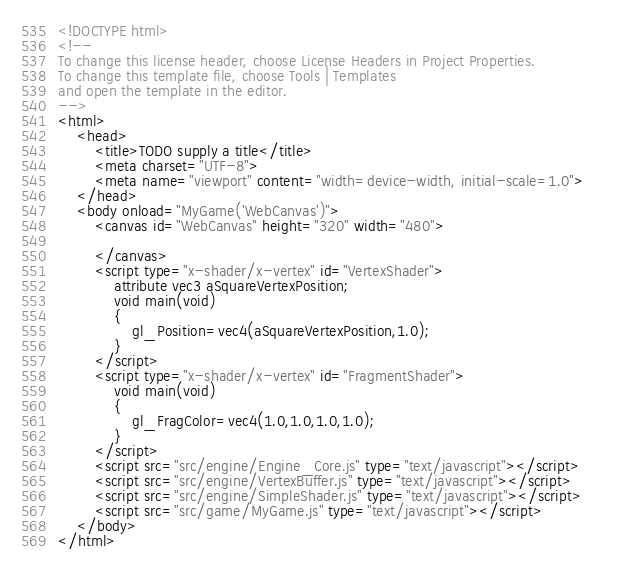Convert code to text. <code><loc_0><loc_0><loc_500><loc_500><_HTML_><!DOCTYPE html>
<!--
To change this license header, choose License Headers in Project Properties.
To change this template file, choose Tools | Templates
and open the template in the editor.
-->
<html>
    <head>
        <title>TODO supply a title</title>
        <meta charset="UTF-8">
        <meta name="viewport" content="width=device-width, initial-scale=1.0">
    </head>
    <body onload="MyGame('WebCanvas')">
        <canvas id="WebCanvas" height="320" width="480">
            
        </canvas>
        <script type="x-shader/x-vertex" id="VertexShader">
            attribute vec3 aSquareVertexPosition;
            void main(void)
            {
                gl_Position=vec4(aSquareVertexPosition,1.0);
            }
        </script>
        <script type="x-shader/x-vertex" id="FragmentShader">
            void main(void)
            {
                gl_FragColor=vec4(1.0,1.0,1.0,1.0);
            }
        </script>
        <script src="src/engine/Engine_Core.js" type="text/javascript"></script>
        <script src="src/engine/VertexBuffer.js" type="text/javascript"></script>
        <script src="src/engine/SimpleShader.js" type="text/javascript"></script>        
        <script src="src/game/MyGame.js" type="text/javascript"></script>
    </body>
</html>
</code> 